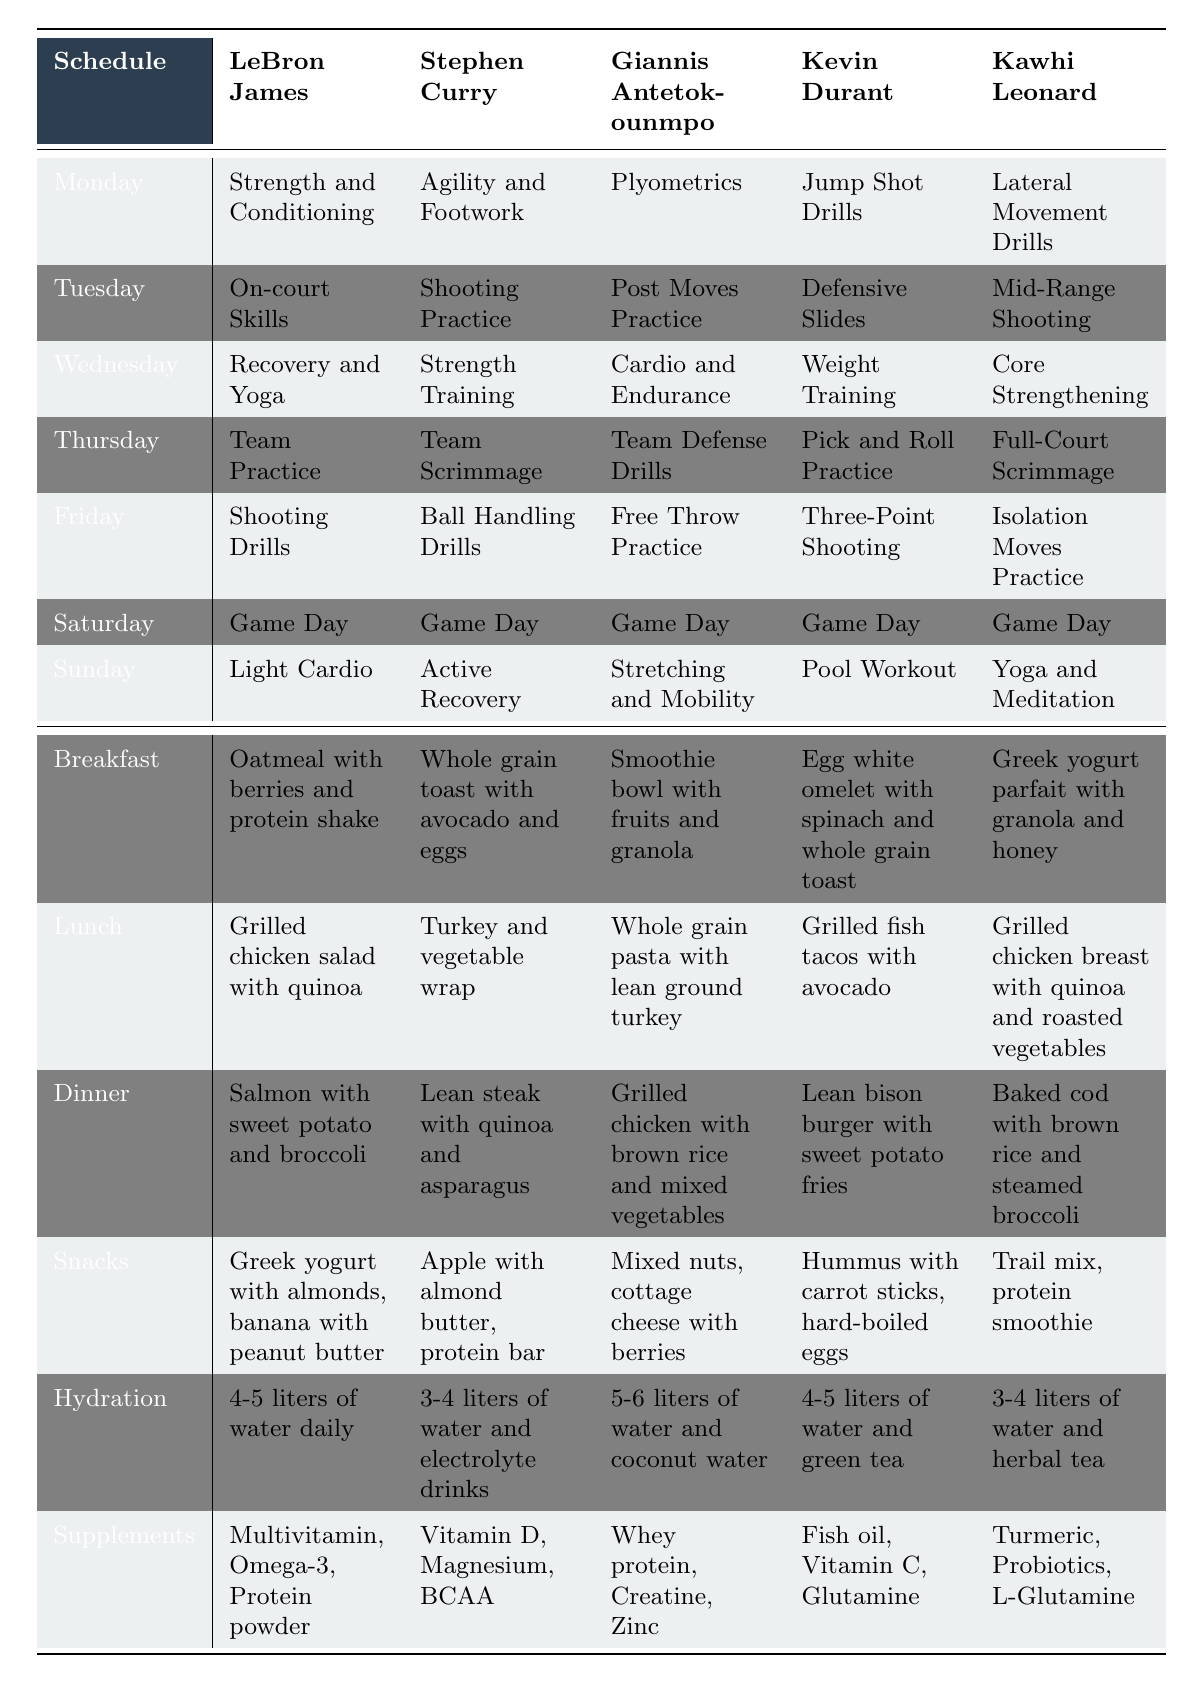What training activity does Kevin Durant do on Wednesday? According to the table, Kevin Durant's training activity on Wednesday is "Weight Training."
Answer: Weight Training Which player has the highest daily water intake? By comparing the hydration values in the table, Giannis Antetokounmpo has the highest daily water intake at 5-6 liters.
Answer: Giannis Antetokounmpo Is there a player who practices shooting on Tuesday? The table shows that both Stephen Curry and Kawhi Leonard practice shooting on Tuesday, making this statement true.
Answer: Yes Which player's dinner includes a bison burger? The table indicates that Kevin Durant's dinner includes a "Lean bison burger with sweet potato fries."
Answer: Kevin Durant How many players have "Game Day" as their Saturday training activity? All five players have "Game Day" as their Saturday training activity, so we count them together.
Answer: 5 What is the difference between the water intake of Stephen Curry and Kawhi Leonard? Stephen Curry's water intake is 3-4 liters and Kawhi Leonard's is 3-4 liters. Since both values are equal, the difference is 0.
Answer: 0 Which player has the most diverse snack options listed? By analyzing the snack options in the table, Kawhi Leonard has trail mix and a protein smoothie, while the others have fewer unique snacks, suggesting he has more diversity.
Answer: Kawhi Leonard What type of supplement does Giannis Antetokounmpo take? The table lists Giannis Antetokounmpo's supplements as "Whey protein, Creatine, Zinc," providing direct information about his supplement type.
Answer: Whey protein, Creatine, Zinc Compare the breakfast options for LeBron James and Kevin Durant. Which one has more protein? LeBron James has "Oatmeal with berries and protein shake" while Kevin Durant has "Egg white omelet with spinach and whole grain toast." The protein shake suggests LeBron might have a higher protein content than the egg white omelet.
Answer: LeBron James On which days do players practice recovery or light training? Reviewing the table, players incorporate recovery or light training on Sunday: LeBron James has "Light Cardio," Stephen Curry has "Active Recovery," Giannis has "Stretching and Mobility," and Kawhi has "Yoga and Meditation." Only Kevin Durant has "Pool Workout."
Answer: Sunday Who has a dietary pattern that includes more fish-based meals? Analyzing the table, both LeBron James (salmon) and Kevin Durant (grilled fish tacos) include fish in their meals, but only two players do, making their pattern centered around more diverse protein sources.
Answer: LeBron James and Kevin Durant 